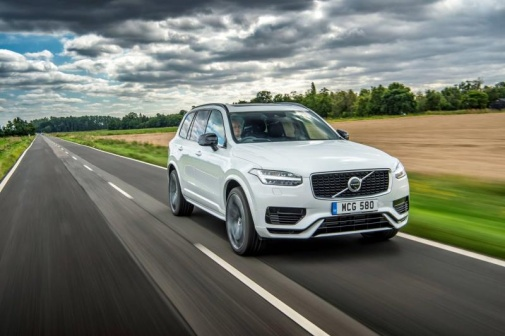Imagine a story that takes place in this setting. In this setting, a family decides to take a spontaneous road trip through the countryside. They've packed a picnic, ready to stop at a scenic spot along the way. As they drive down the wet, glistening road, they recount childhood stories and sing along to their favorite tunes, their laughter mingling with the sound of the car's tires on the damp pavement. The recent rain has left the landscape particularly vivid, giving them the perfect backdrop for creating new memories. They pull over by a field, lay out their picnic, and enjoy a peaceful, joyous afternoon under the whimsically cloudy sky. 